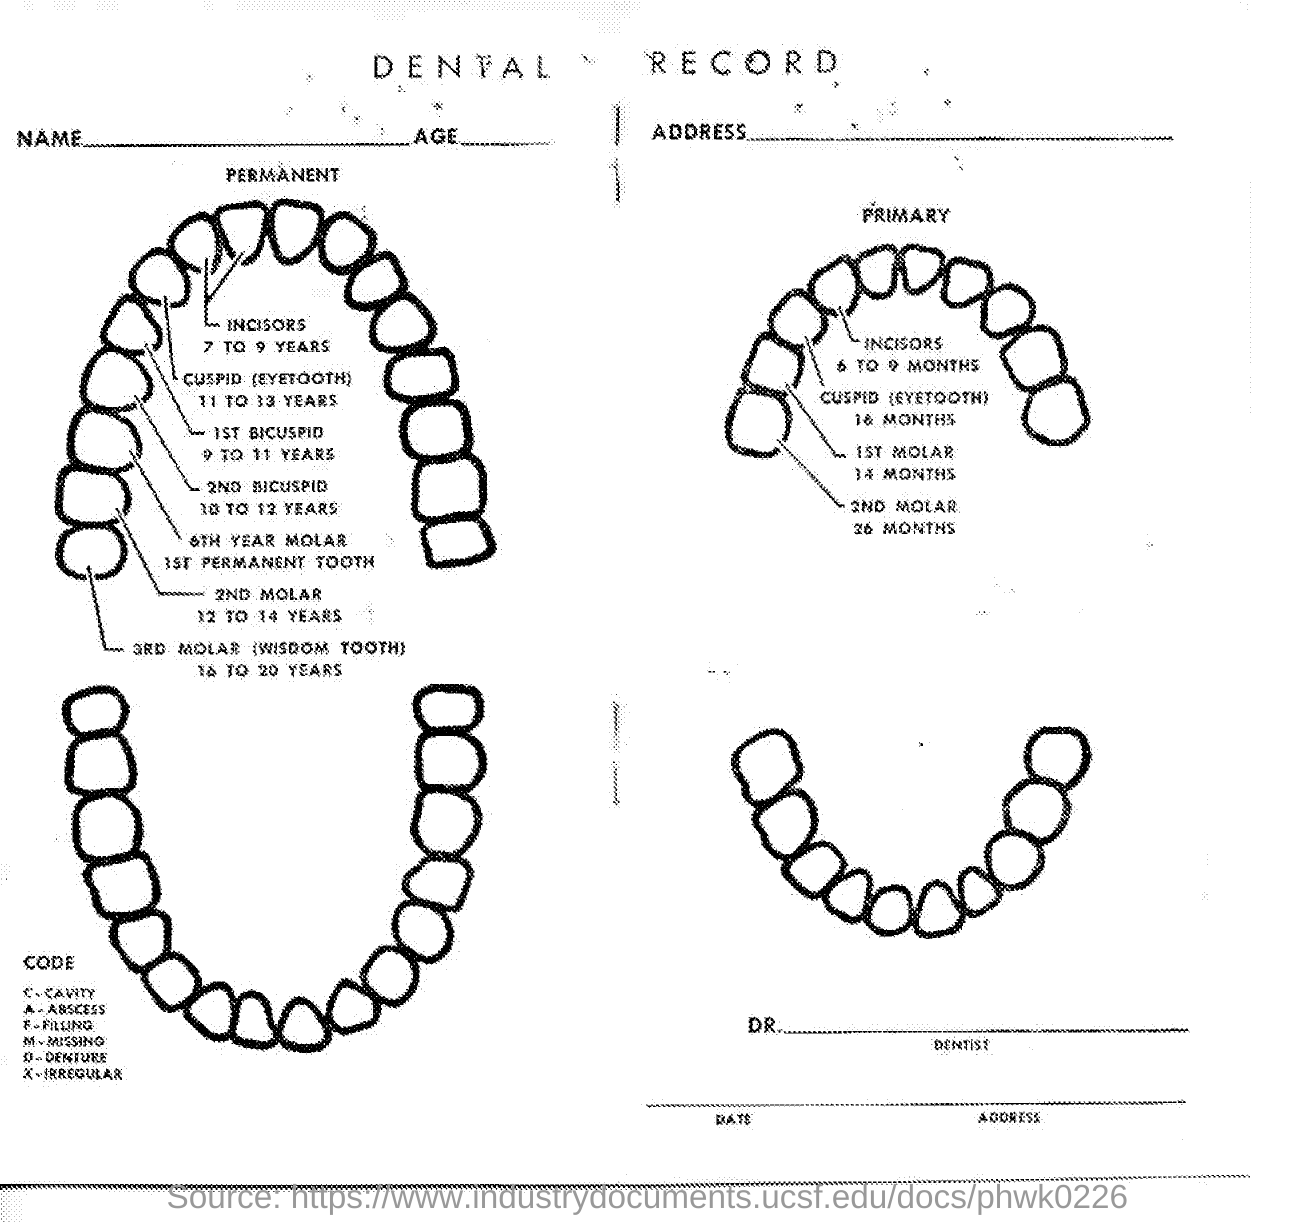Point out several critical features in this image. The permanent incisors typically erupt between the ages of 7 and 9 years. The document title is Dental Record. The term '3RD MOLAR' is another name for the 'WISDOM TOOTH'. 